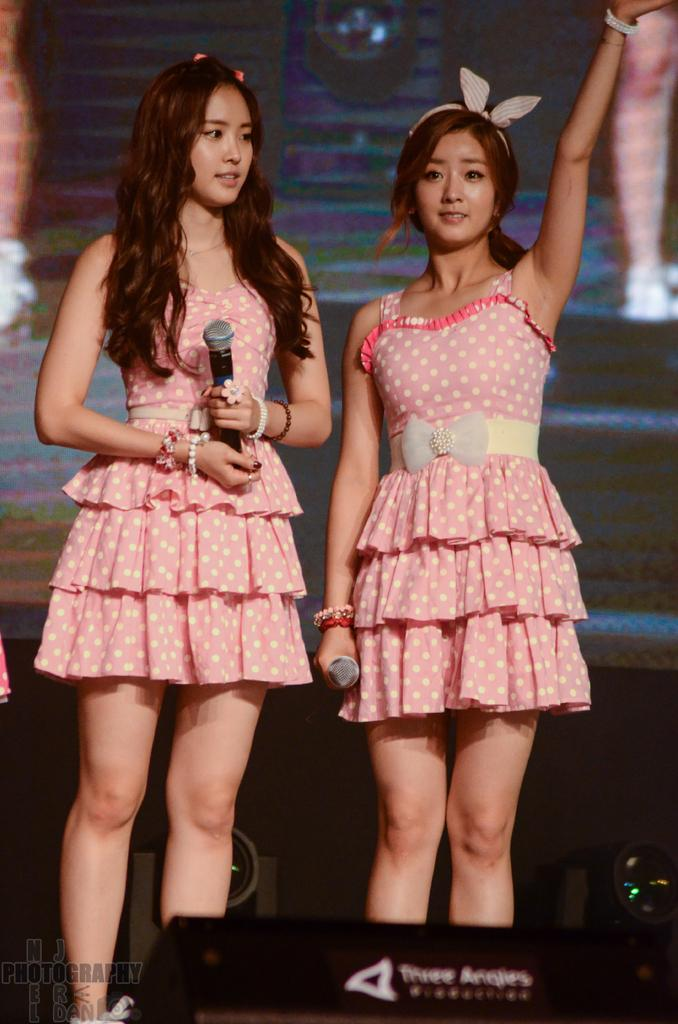How many people are in the image? There are two persons in the image. What are the persons wearing? Both persons are wearing similar dress. Where are the persons standing? The persons are standing on a stage. What are the persons holding in their hands? Each person is holding a microphone in their hand. What type of juice can be seen in the basin on the stage? There is no juice or basin present in the image; the persons are holding microphones and standing on a stage. 